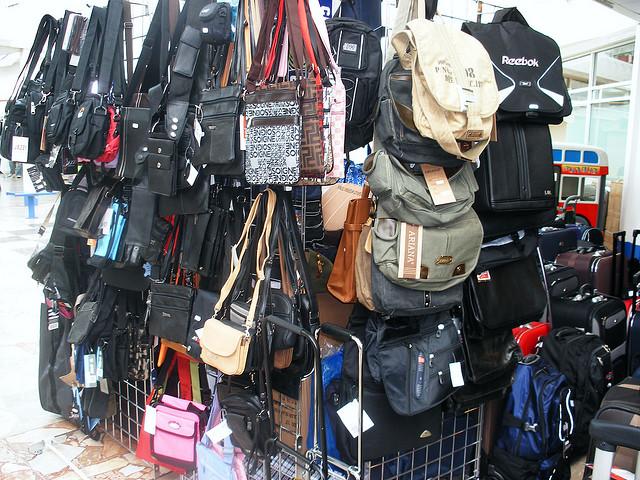Is this a store?
Be succinct. Yes. Are these items new or used?
Concise answer only. New. Where are the backpacks?
Be succinct. On rack. 